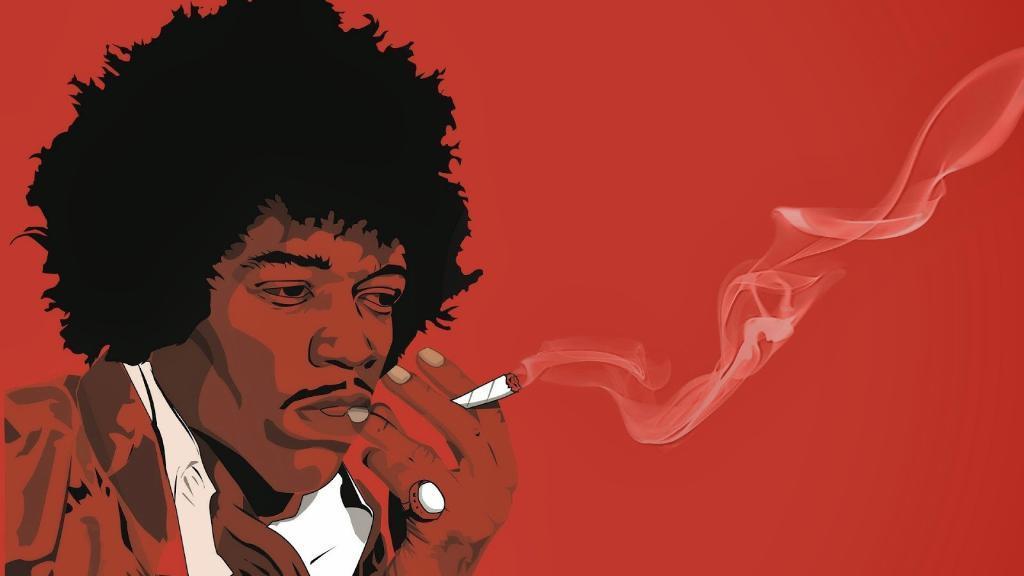Can you describe this image briefly? In this picture I can see a man is smoking, it looks like an animation. 